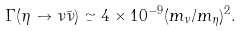<formula> <loc_0><loc_0><loc_500><loc_500>\Gamma ( \eta \to \nu \bar { \nu } ) \simeq 4 \times 1 0 ^ { - 9 } ( m _ { \nu } / m _ { \eta } ) ^ { 2 } .</formula> 